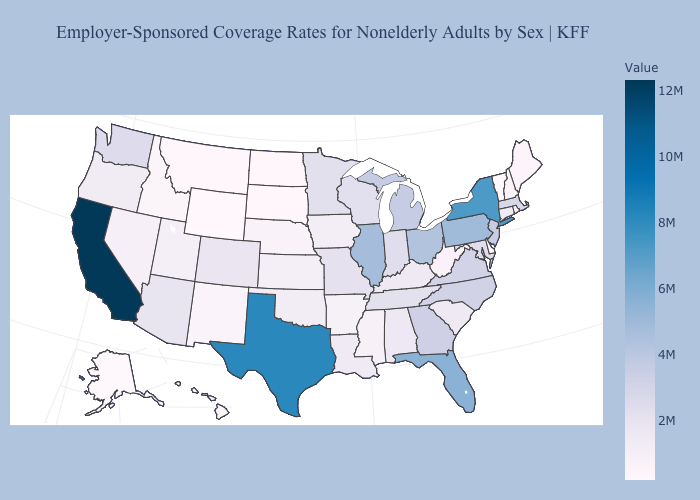Among the states that border Maryland , does Pennsylvania have the highest value?
Give a very brief answer. Yes. Does Illinois have the highest value in the MidWest?
Give a very brief answer. Yes. Does Georgia have the lowest value in the USA?
Be succinct. No. Among the states that border Alabama , does Mississippi have the lowest value?
Quick response, please. Yes. Does Indiana have a higher value than Florida?
Short answer required. No. Which states have the highest value in the USA?
Answer briefly. California. Among the states that border Florida , which have the lowest value?
Concise answer only. Alabama. Which states have the highest value in the USA?
Answer briefly. California. Among the states that border Minnesota , does South Dakota have the highest value?
Answer briefly. No. 